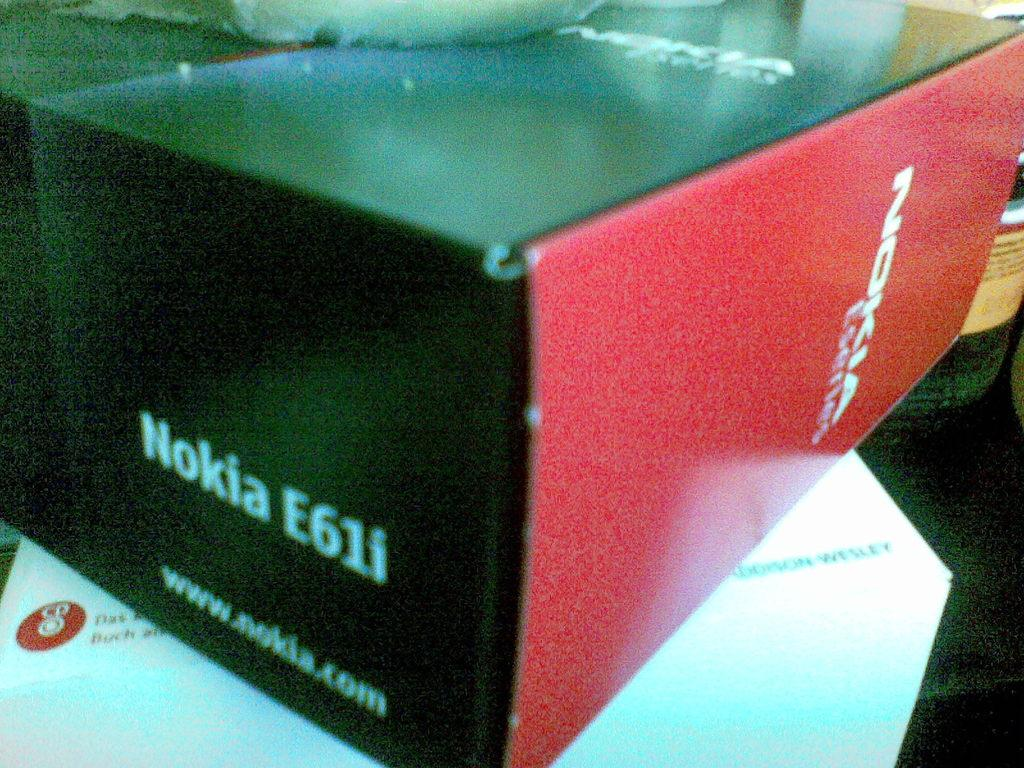Provide a one-sentence caption for the provided image. A grainy close up shot of a Nokia E61i box. 